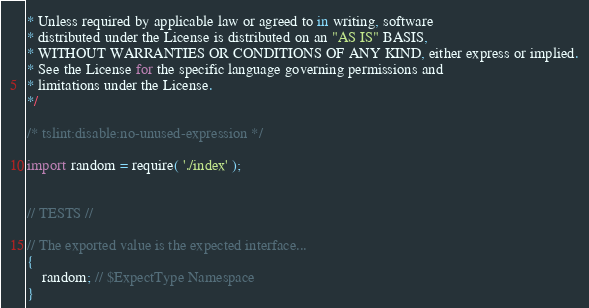Convert code to text. <code><loc_0><loc_0><loc_500><loc_500><_TypeScript_>* Unless required by applicable law or agreed to in writing, software
* distributed under the License is distributed on an "AS IS" BASIS,
* WITHOUT WARRANTIES OR CONDITIONS OF ANY KIND, either express or implied.
* See the License for the specific language governing permissions and
* limitations under the License.
*/

/* tslint:disable:no-unused-expression */

import random = require( './index' );


// TESTS //

// The exported value is the expected interface...
{
	random; // $ExpectType Namespace
}
</code> 